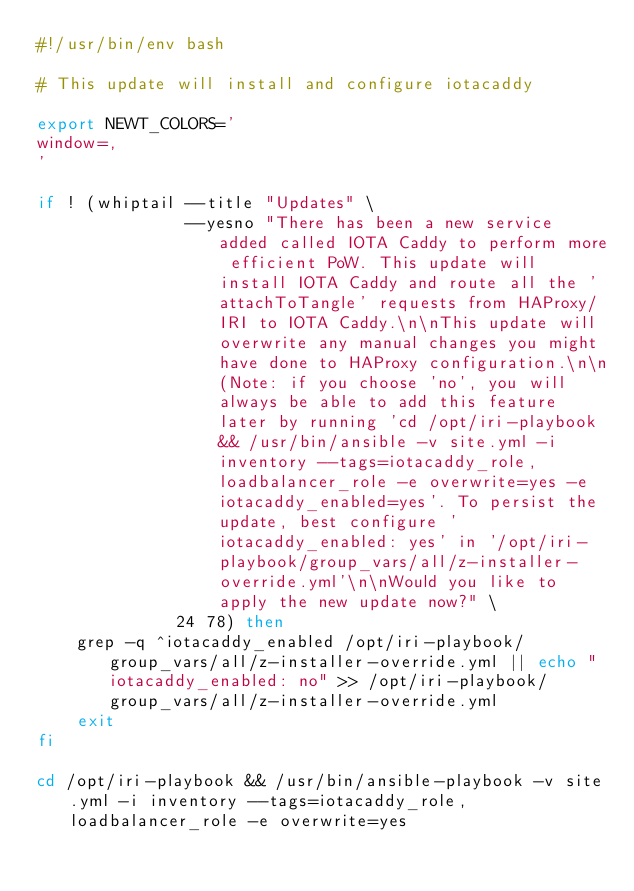<code> <loc_0><loc_0><loc_500><loc_500><_Bash_>#!/usr/bin/env bash

# This update will install and configure iotacaddy

export NEWT_COLORS='
window=,
'

if ! (whiptail --title "Updates" \
               --yesno "There has been a new service added called IOTA Caddy to perform more efficient PoW. This update will install IOTA Caddy and route all the 'attachToTangle' requests from HAProxy/IRI to IOTA Caddy.\n\nThis update will overwrite any manual changes you might have done to HAProxy configuration.\n\n(Note: if you choose 'no', you will always be able to add this feature later by running 'cd /opt/iri-playbook && /usr/bin/ansible -v site.yml -i inventory --tags=iotacaddy_role,loadbalancer_role -e overwrite=yes -e iotacaddy_enabled=yes'. To persist the update, best configure 'iotacaddy_enabled: yes' in '/opt/iri-playbook/group_vars/all/z-installer-override.yml'\n\nWould you like to apply the new update now?" \
              24 78) then
    grep -q ^iotacaddy_enabled /opt/iri-playbook/group_vars/all/z-installer-override.yml || echo "iotacaddy_enabled: no" >> /opt/iri-playbook/group_vars/all/z-installer-override.yml
    exit
fi

cd /opt/iri-playbook && /usr/bin/ansible-playbook -v site.yml -i inventory --tags=iotacaddy_role,loadbalancer_role -e overwrite=yes
</code> 